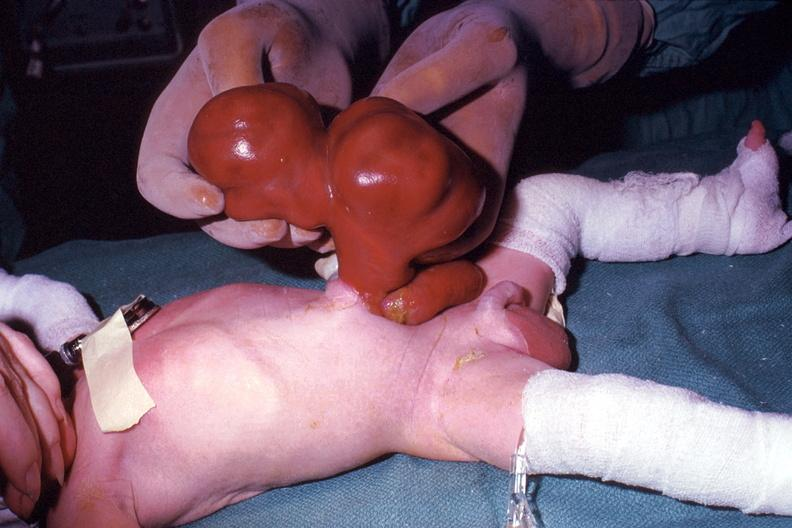where is this area in the body?
Answer the question using a single word or phrase. Abdomen 